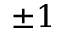Convert formula to latex. <formula><loc_0><loc_0><loc_500><loc_500>\pm 1</formula> 